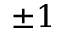Convert formula to latex. <formula><loc_0><loc_0><loc_500><loc_500>\pm 1</formula> 